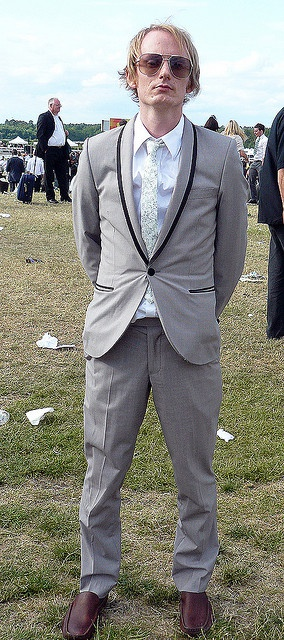Describe the objects in this image and their specific colors. I can see people in white, gray, darkgray, lightgray, and black tones, people in white, black, gray, and blue tones, people in white, black, lavender, gray, and darkgray tones, tie in white, lightgray, darkgray, and lightblue tones, and people in white, black, lightgray, gray, and darkgray tones in this image. 